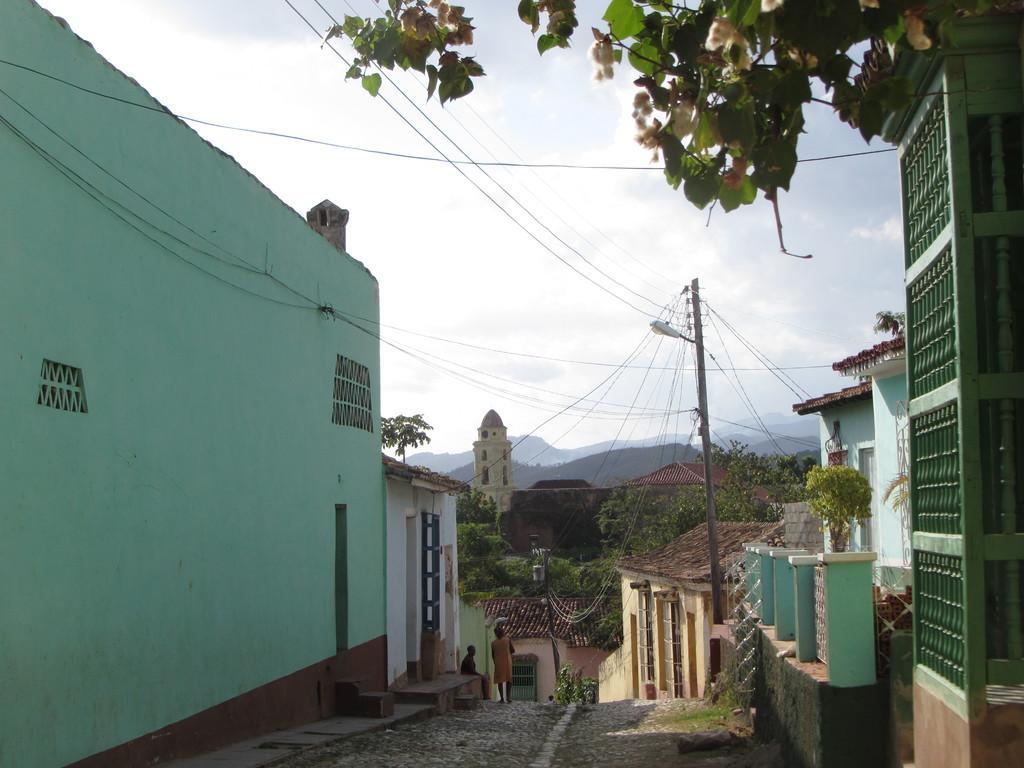Please provide a concise description of this image. In this image a person is standing on the land. A person is sitting on the floor before a house. Background there are few plants, trees and few buildings. Top of image there is sky. Right top there are few branches having leaves and flowers. There is a pole having a lamp and few wires are connected to it. 